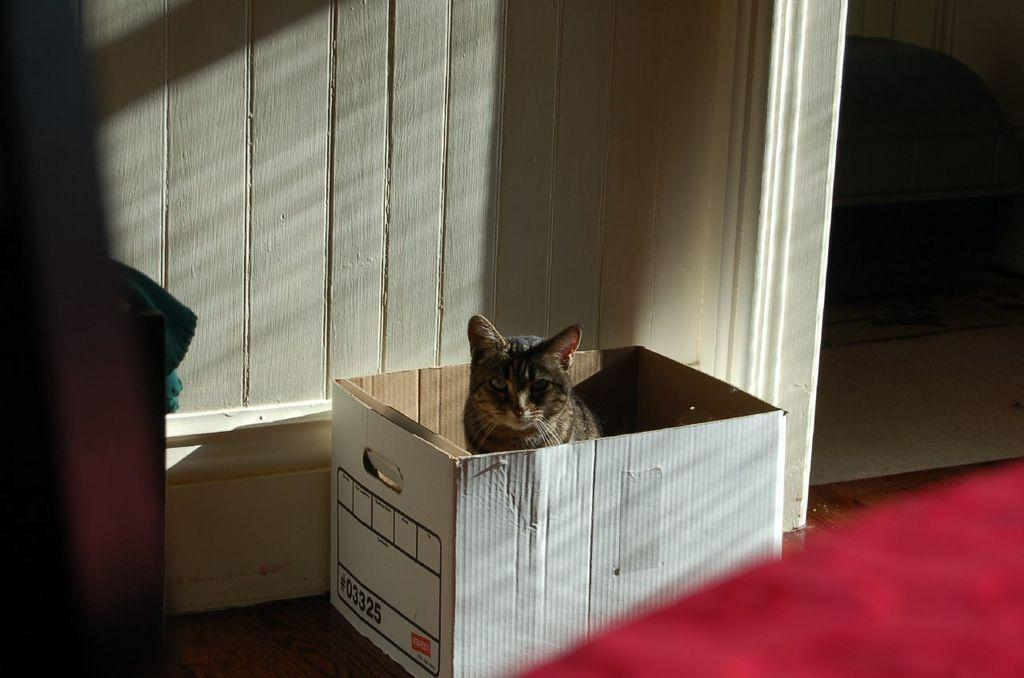What type of animal is in the image? There is a cat in the image. Where is the cat located in the image? The cat is in a cardboard box. What can be seen in the background of the image? There is a wall visible in the background of the image. Can you tell me how many babies are in the image? There are no babies present in the image; it features a cat in a cardboard box. What type of country is depicted in the image? There is no country depicted in the image; it features a cat in a cardboard box and a wall in the background. 